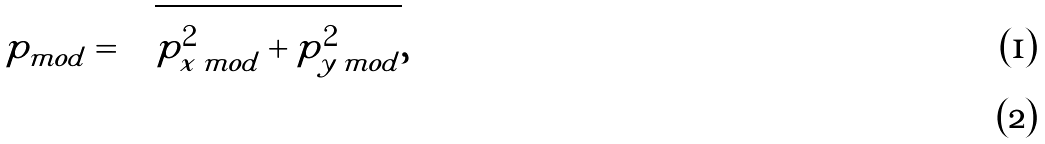Convert formula to latex. <formula><loc_0><loc_0><loc_500><loc_500>p _ { m o d } = \sqrt { p ^ { 2 } _ { x \, m o d } + p ^ { 2 } _ { y \, m o d } } , \\</formula> 